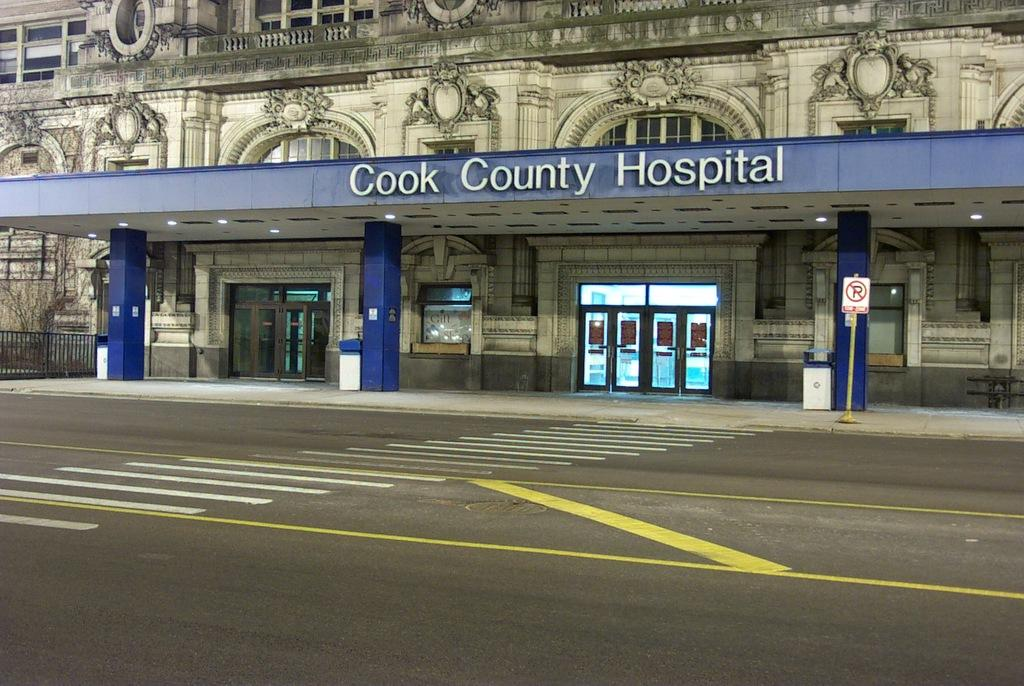Provide a one-sentence caption for the provided image. The entrance to Cook County Hospital has a pull up area with a blue overhead. 